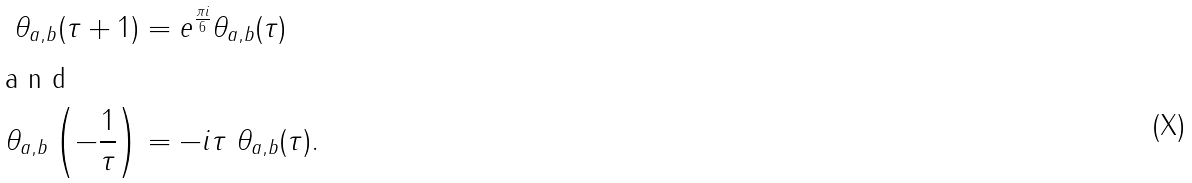<formula> <loc_0><loc_0><loc_500><loc_500>\theta _ { a , b } ( \tau + 1 ) & = e ^ { \frac { \pi i } { 6 } } \theta _ { a , b } ( \tau ) \\ \intertext { a n d } \theta _ { a , b } \left ( - \frac { 1 } { \tau } \right ) & = - i \tau \ \theta _ { a , b } ( \tau ) .</formula> 